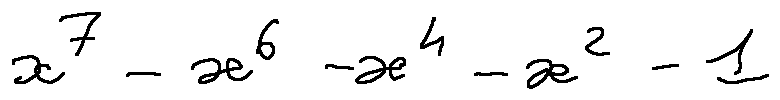Convert formula to latex. <formula><loc_0><loc_0><loc_500><loc_500>x ^ { 7 } - x ^ { 6 } - x ^ { 4 } - x ^ { 2 } - 1</formula> 